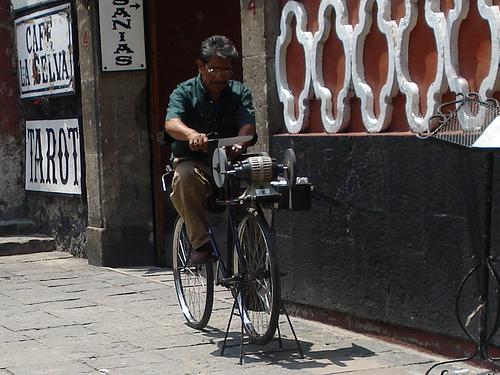Can he be sharpening blades?
Be succinct. Yes. How heavy is this man?
Give a very brief answer. Medium heaviness. Is this a normal thing to see in recent history?
Short answer required. No. What is man doing on his cycle?
Keep it brief. Sharpening knife. 